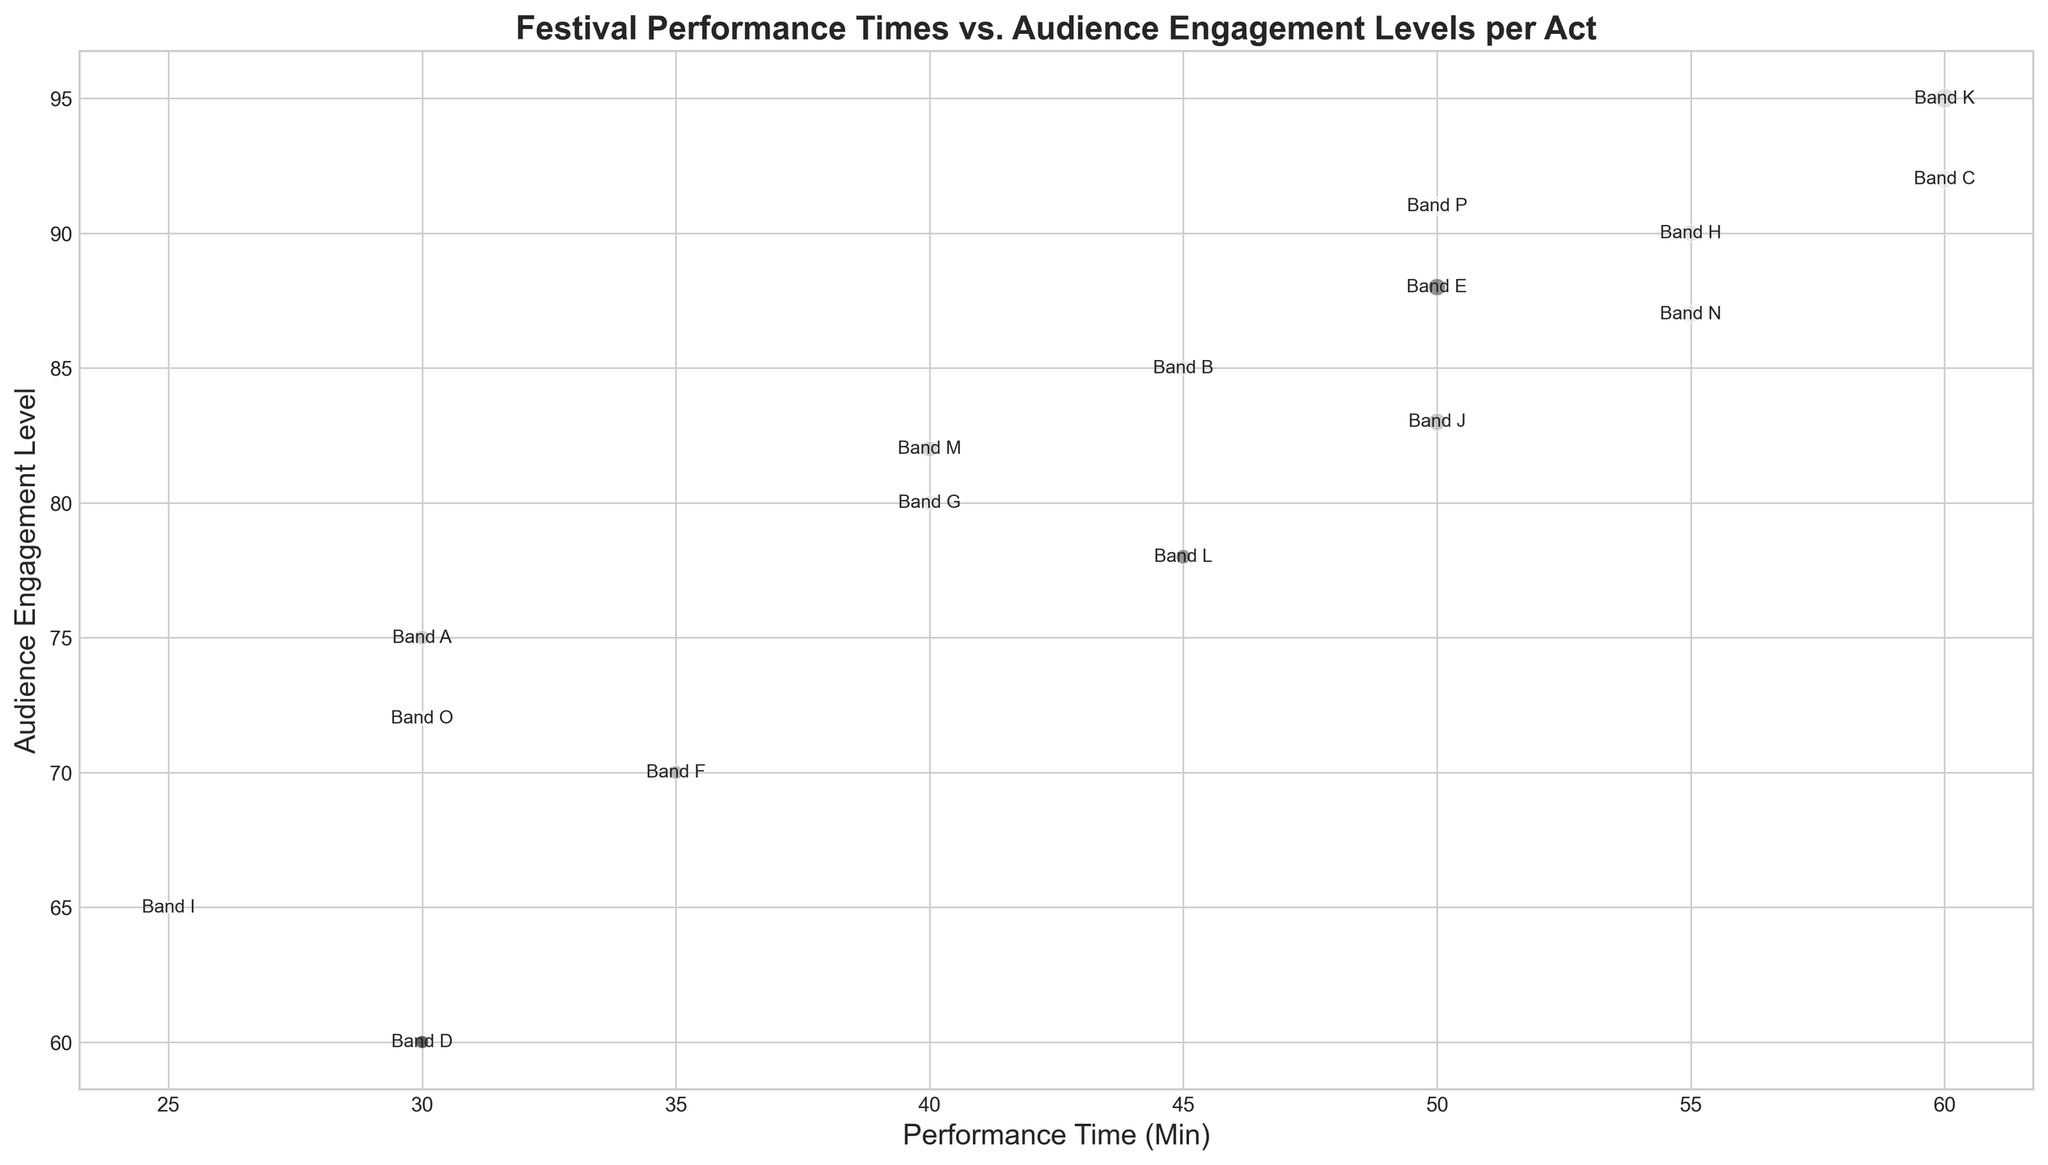Which act had the longest performance time? Looking at the x-axis which denotes the performance time, we see that 'Band C' and 'Band K' have the longest performance time marked at 60 minutes.
Answer: Band C, Band K Which act had the highest audience engagement level? Referring to the y-axis which represents audience engagement level, 'Band K' has the highest value at 95.
Answer: Band K Which act attracted the largest audience size? The size of the bubbles represents the audience size. 'Band K' has the largest bubble, indicating the highest audience size of 900.
Answer: Band K What is the average performance time of all acts? Add up all performance times: 30 + 45 + 60 + 30 + 50 + 35 + 40 + 55 + 25 + 50 + 60 + 45 + 40 + 55 + 30 + 50 = 700. Divide by the number of acts (16): 700 / 16 = 43.75.
Answer: 43.75 Which acts have an audience engagement level greater than 90? From the chart, 'Band C', 'Band H', 'Band K' and 'Band P' have engagement levels above 90.
Answer: Band C, Band H, Band K, Band P Is there any act that had a performance time of 30 minutes and an audience engagement level lower than 70? Observing the chart, 'Band D' fits this description with a performance time of 30 minutes and engagement level of 60.
Answer: Band D Between Band B and Band L, which act had a higher audience engagement level? Comparing their positions on the y-axis: 'Band B' at 85 and 'Band L' at 78. 'Band B' has the higher audience engagement level.
Answer: Band B What is the combined audience size of Band E and Band J? Band E's audience size is 700, and Band J's audience size is 710. Sum: 700 + 710 = 1410.
Answer: 1410 How many acts have a performance time between 40 and 50 minutes? From the x-axis, the bands are 'Band G', 'Band J', and 'Band M', making a total of 3 bands.
Answer: 3 Which acts have both performance times of 50 minutes and engagement levels greater than 88? 'Band E' and 'Band P' have performance times of 50 minutes with engagement levels of 88 and 91 respectively.
Answer: Band E, Band P 